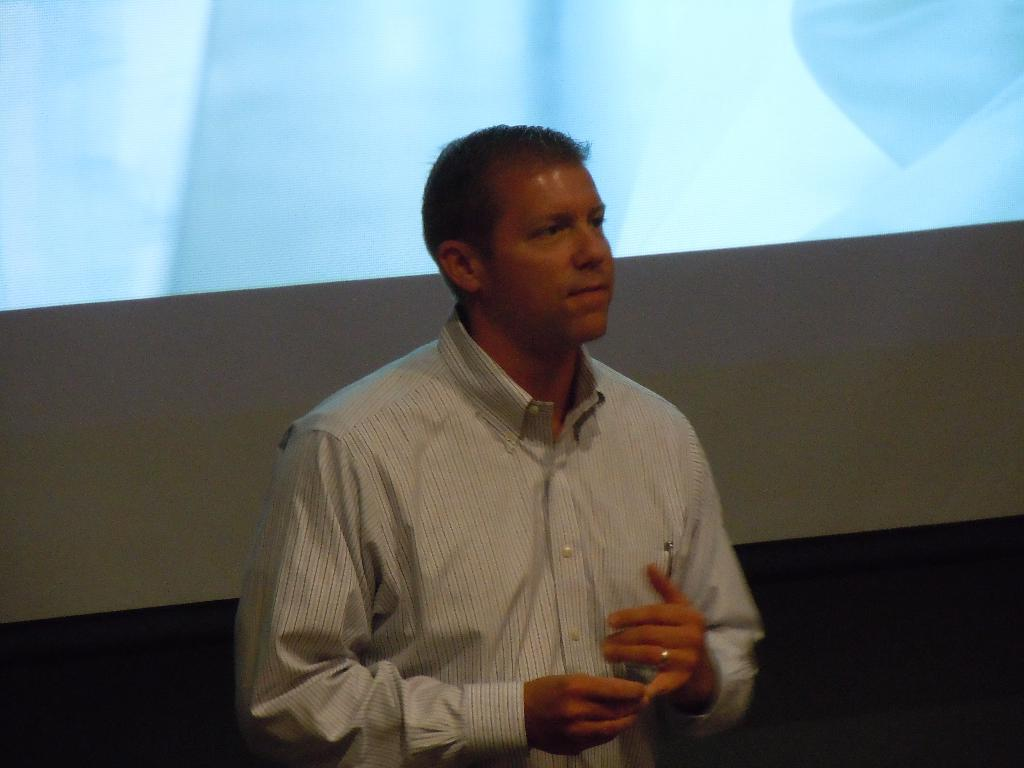What is the main subject of the image? There is a person standing in the center of the image. What can be seen in the background of the image? There is a wall and a screen in the background of the image. What type of straw is being used by the person in the image? There is no straw present in the image. What form does the person in the image take? The person in the image is depicted in a human form, as they are standing. What is the limit of the person's movement in the image? The person in the image is standing, so their movement is limited to their current position. 